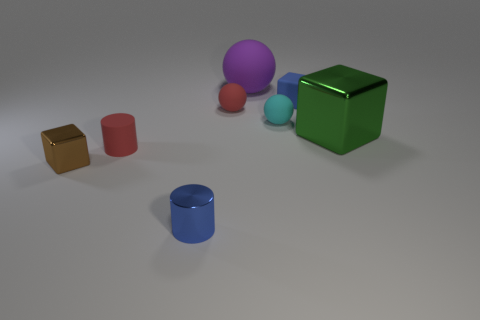Are there fewer small cyan things that are in front of the large shiny cube than blue cylinders that are on the left side of the brown thing?
Provide a short and direct response. No. What number of tiny red balls have the same material as the tiny brown block?
Provide a succinct answer. 0. There is a small blue thing that is left of the tiny blue object behind the green metallic object; are there any big purple matte objects that are in front of it?
Your answer should be compact. No. What number of cubes are either green shiny objects or red things?
Your answer should be very brief. 1. Does the large green metallic thing have the same shape as the red thing behind the green block?
Keep it short and to the point. No. Is the number of red rubber balls that are behind the small blue block less than the number of tiny red cubes?
Provide a short and direct response. No. Are there any tiny blue cylinders to the right of the blue cylinder?
Keep it short and to the point. No. Are there any small metal objects of the same shape as the large purple matte object?
Ensure brevity in your answer.  No. There is a rubber thing that is the same size as the green cube; what is its shape?
Ensure brevity in your answer.  Sphere. How many objects are either matte objects on the right side of the cyan matte thing or purple matte objects?
Provide a short and direct response. 2. 